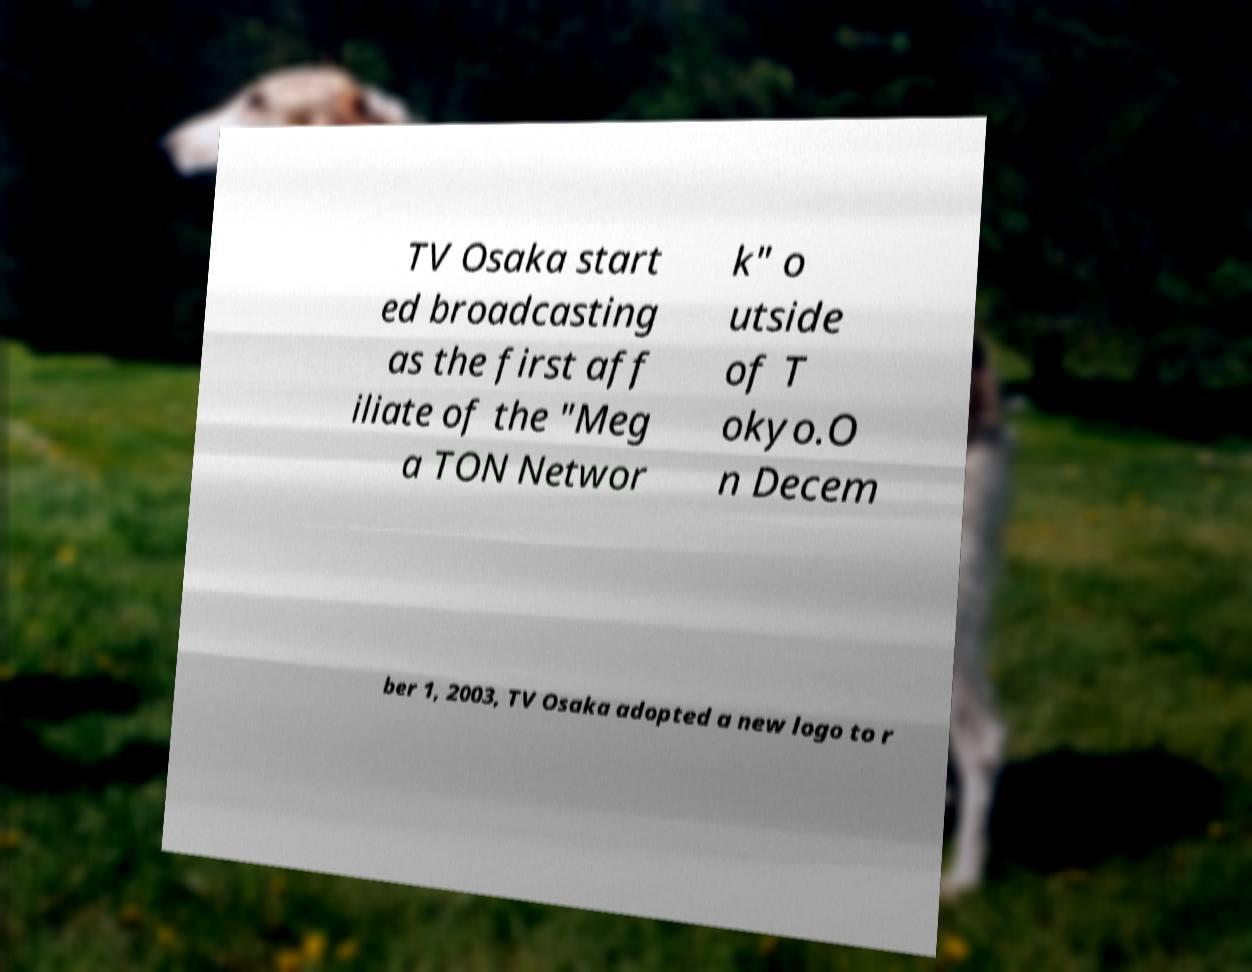Please identify and transcribe the text found in this image. TV Osaka start ed broadcasting as the first aff iliate of the "Meg a TON Networ k" o utside of T okyo.O n Decem ber 1, 2003, TV Osaka adopted a new logo to r 